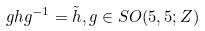<formula> <loc_0><loc_0><loc_500><loc_500>g h g ^ { - 1 } = \tilde { h } , g \in S O ( 5 , 5 ; { Z } )</formula> 